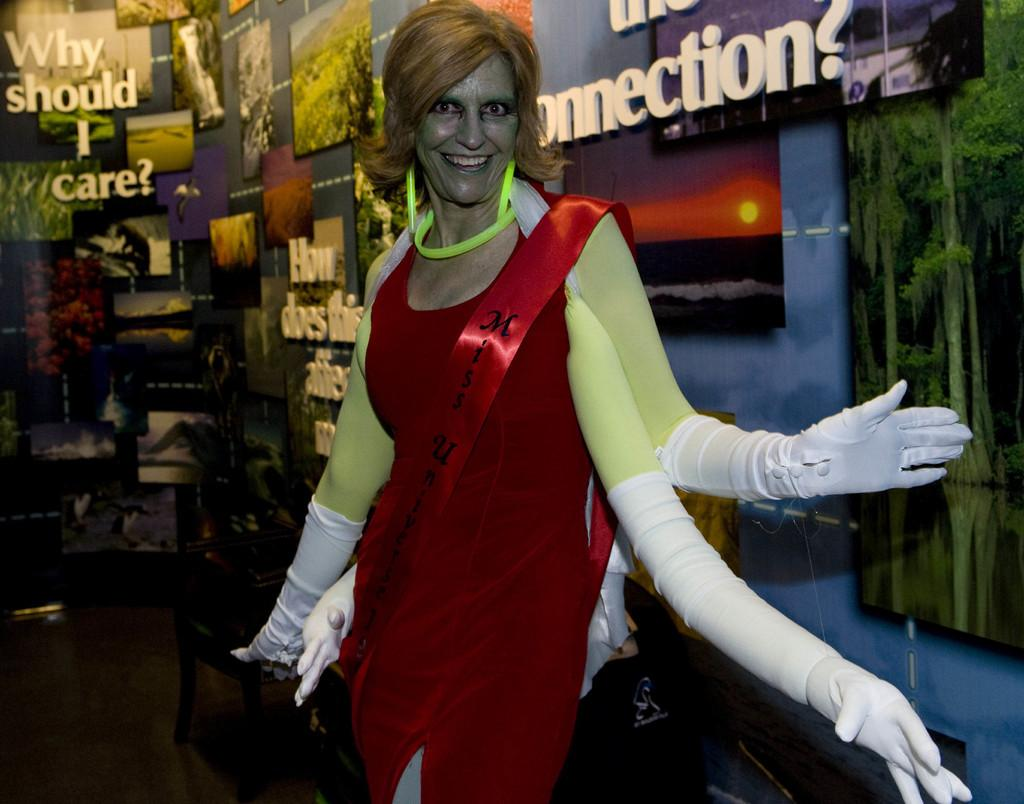What is the main subject in the center of the image? There is a person with costumes in the center of the image. What can be seen on the wall in the background of the image? There are photo frames on the wall in the background of the image. What type of yard can be seen in the image? There is no yard visible in the image; it features a person with costumes and photo frames on the wall. 